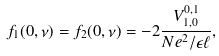<formula> <loc_0><loc_0><loc_500><loc_500>f _ { 1 } ( 0 , \nu ) = f _ { 2 } ( 0 , \nu ) = - 2 \frac { V _ { 1 , 0 } ^ { 0 , 1 } } { N e ^ { 2 } / \epsilon \ell } ,</formula> 